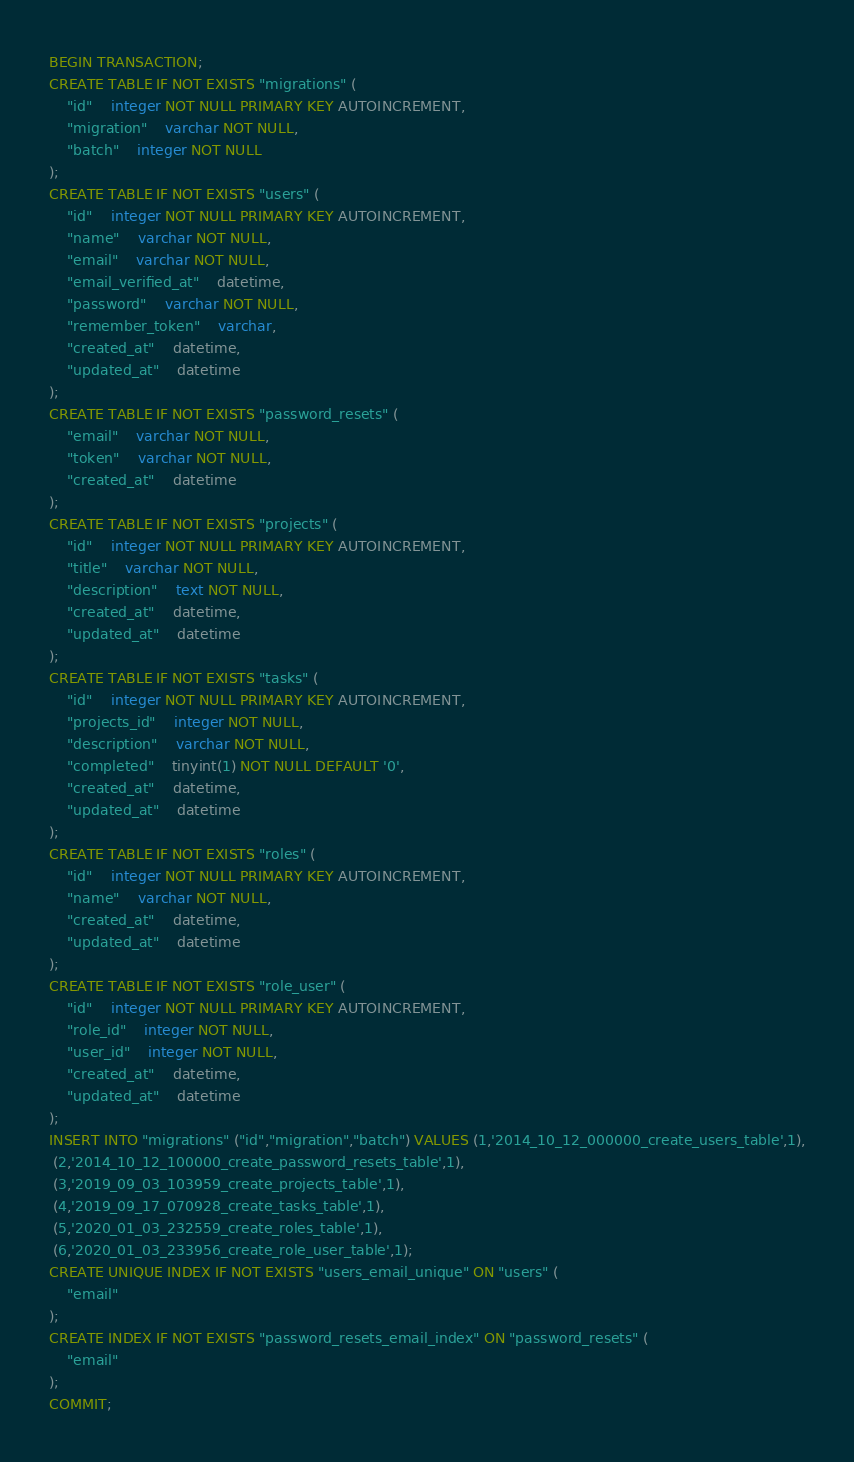Convert code to text. <code><loc_0><loc_0><loc_500><loc_500><_SQL_>BEGIN TRANSACTION;
CREATE TABLE IF NOT EXISTS "migrations" (
	"id"	integer NOT NULL PRIMARY KEY AUTOINCREMENT,
	"migration"	varchar NOT NULL,
	"batch"	integer NOT NULL
);
CREATE TABLE IF NOT EXISTS "users" (
	"id"	integer NOT NULL PRIMARY KEY AUTOINCREMENT,
	"name"	varchar NOT NULL,
	"email"	varchar NOT NULL,
	"email_verified_at"	datetime,
	"password"	varchar NOT NULL,
	"remember_token"	varchar,
	"created_at"	datetime,
	"updated_at"	datetime
);
CREATE TABLE IF NOT EXISTS "password_resets" (
	"email"	varchar NOT NULL,
	"token"	varchar NOT NULL,
	"created_at"	datetime
);
CREATE TABLE IF NOT EXISTS "projects" (
	"id"	integer NOT NULL PRIMARY KEY AUTOINCREMENT,
	"title"	varchar NOT NULL,
	"description"	text NOT NULL,
	"created_at"	datetime,
	"updated_at"	datetime
);
CREATE TABLE IF NOT EXISTS "tasks" (
	"id"	integer NOT NULL PRIMARY KEY AUTOINCREMENT,
	"projects_id"	integer NOT NULL,
	"description"	varchar NOT NULL,
	"completed"	tinyint(1) NOT NULL DEFAULT '0',
	"created_at"	datetime,
	"updated_at"	datetime
);
CREATE TABLE IF NOT EXISTS "roles" (
	"id"	integer NOT NULL PRIMARY KEY AUTOINCREMENT,
	"name"	varchar NOT NULL,
	"created_at"	datetime,
	"updated_at"	datetime
);
CREATE TABLE IF NOT EXISTS "role_user" (
	"id"	integer NOT NULL PRIMARY KEY AUTOINCREMENT,
	"role_id"	integer NOT NULL,
	"user_id"	integer NOT NULL,
	"created_at"	datetime,
	"updated_at"	datetime
);
INSERT INTO "migrations" ("id","migration","batch") VALUES (1,'2014_10_12_000000_create_users_table',1),
 (2,'2014_10_12_100000_create_password_resets_table',1),
 (3,'2019_09_03_103959_create_projects_table',1),
 (4,'2019_09_17_070928_create_tasks_table',1),
 (5,'2020_01_03_232559_create_roles_table',1),
 (6,'2020_01_03_233956_create_role_user_table',1);
CREATE UNIQUE INDEX IF NOT EXISTS "users_email_unique" ON "users" (
	"email"
);
CREATE INDEX IF NOT EXISTS "password_resets_email_index" ON "password_resets" (
	"email"
);
COMMIT;
</code> 